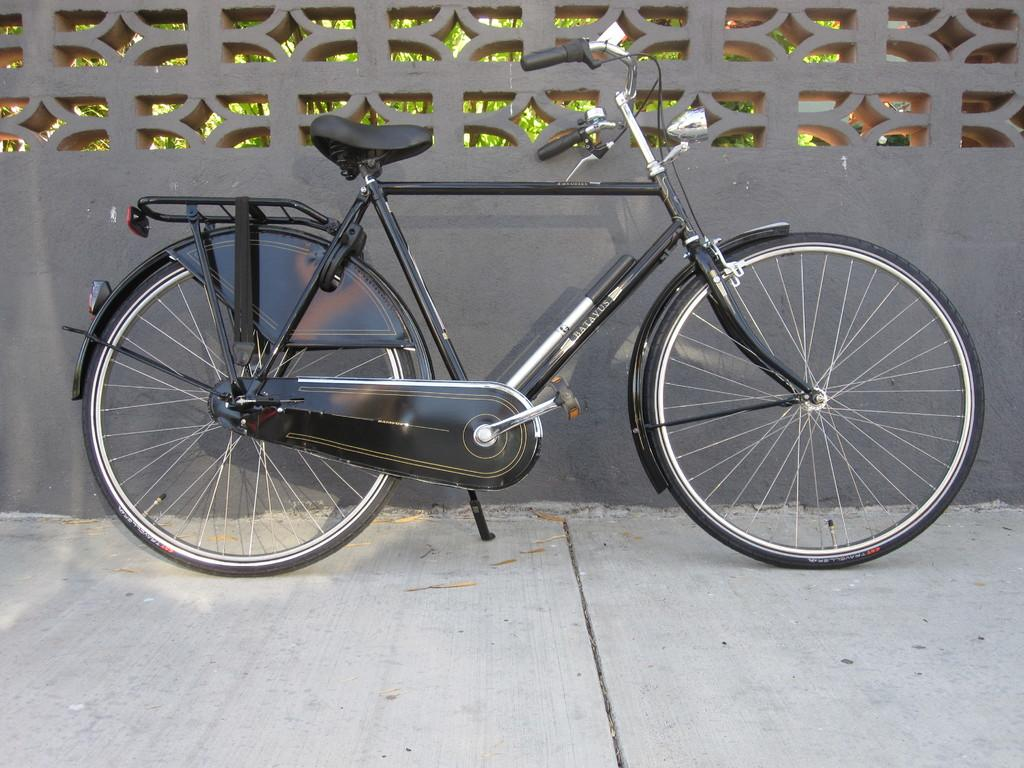What is the main object in the image? There is a bicycle in the image. What color is the bicycle? The bicycle is black in color. What can be seen on the wall in the background? The background wall is gray in color. What type of vegetation is present in the image? There are plants in the image. What color are the plants? The plants are green in color. How many heads of lettuce can be seen in the image? There are no heads of lettuce present in the image. Can you tell me how the bicycle is helping the plants grow? The bicycle is not helping the plants grow in the image; it is a separate object. 